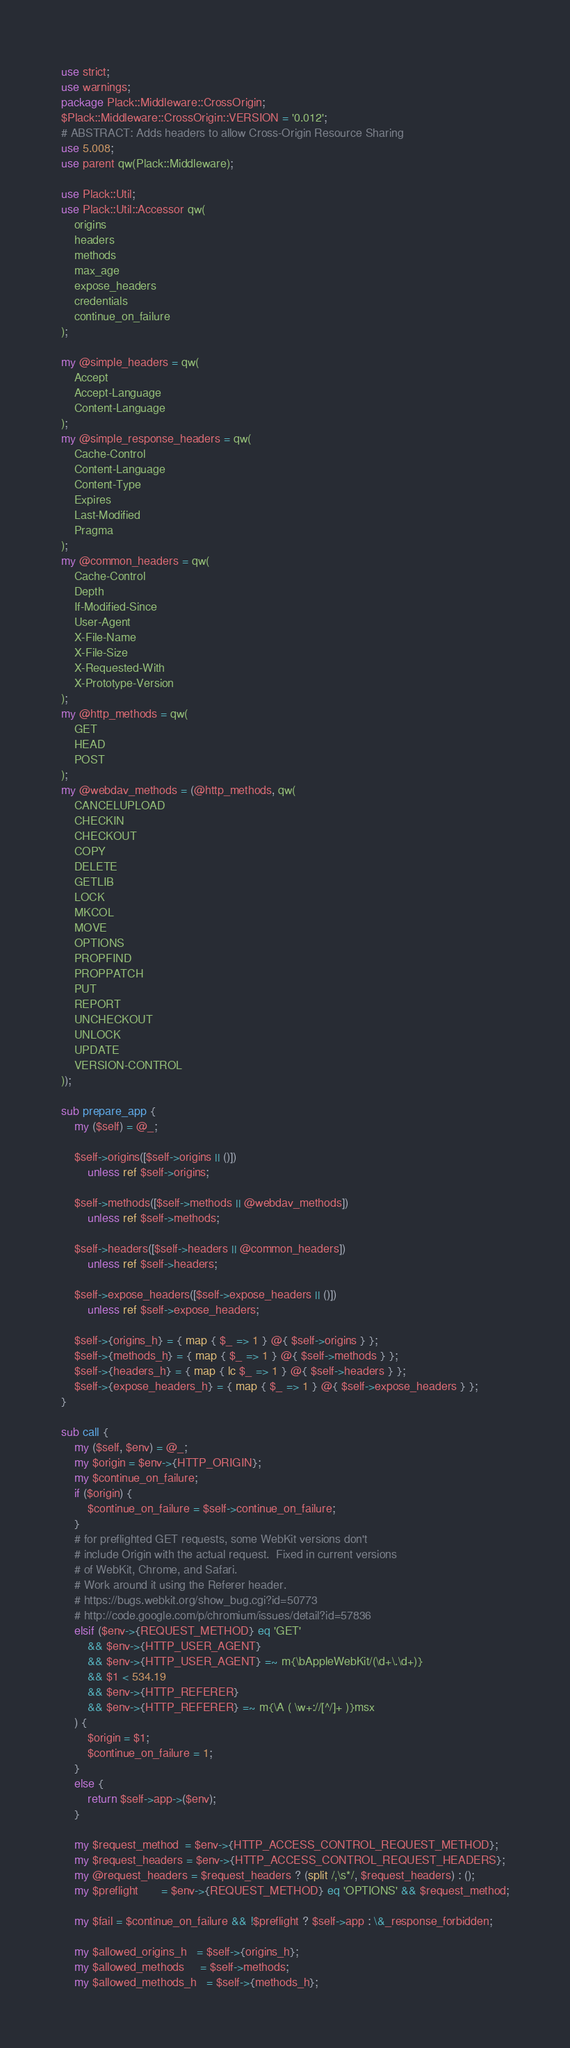<code> <loc_0><loc_0><loc_500><loc_500><_Perl_>use strict;
use warnings;
package Plack::Middleware::CrossOrigin;
$Plack::Middleware::CrossOrigin::VERSION = '0.012';
# ABSTRACT: Adds headers to allow Cross-Origin Resource Sharing
use 5.008;
use parent qw(Plack::Middleware);

use Plack::Util;
use Plack::Util::Accessor qw(
    origins
    headers
    methods
    max_age
    expose_headers
    credentials
    continue_on_failure
);

my @simple_headers = qw(
    Accept
    Accept-Language
    Content-Language
);
my @simple_response_headers = qw(
    Cache-Control
    Content-Language
    Content-Type
    Expires
    Last-Modified
    Pragma
);
my @common_headers = qw(
    Cache-Control
    Depth
    If-Modified-Since
    User-Agent
    X-File-Name
    X-File-Size
    X-Requested-With
    X-Prototype-Version
);
my @http_methods = qw(
    GET
    HEAD
    POST
);
my @webdav_methods = (@http_methods, qw(
    CANCELUPLOAD
    CHECKIN
    CHECKOUT
    COPY
    DELETE
    GETLIB
    LOCK
    MKCOL
    MOVE
    OPTIONS
    PROPFIND
    PROPPATCH
    PUT
    REPORT
    UNCHECKOUT
    UNLOCK
    UPDATE
    VERSION-CONTROL
));

sub prepare_app {
    my ($self) = @_;

    $self->origins([$self->origins || ()])
        unless ref $self->origins;

    $self->methods([$self->methods || @webdav_methods])
        unless ref $self->methods;

    $self->headers([$self->headers || @common_headers])
        unless ref $self->headers;

    $self->expose_headers([$self->expose_headers || ()])
        unless ref $self->expose_headers;

    $self->{origins_h} = { map { $_ => 1 } @{ $self->origins } };
    $self->{methods_h} = { map { $_ => 1 } @{ $self->methods } };
    $self->{headers_h} = { map { lc $_ => 1 } @{ $self->headers } };
    $self->{expose_headers_h} = { map { $_ => 1 } @{ $self->expose_headers } };
}

sub call {
    my ($self, $env) = @_;
    my $origin = $env->{HTTP_ORIGIN};
    my $continue_on_failure;
    if ($origin) {
        $continue_on_failure = $self->continue_on_failure;
    }
    # for preflighted GET requests, some WebKit versions don't
    # include Origin with the actual request.  Fixed in current versions
    # of WebKit, Chrome, and Safari.
    # Work around it using the Referer header.
    # https://bugs.webkit.org/show_bug.cgi?id=50773
    # http://code.google.com/p/chromium/issues/detail?id=57836
    elsif ($env->{REQUEST_METHOD} eq 'GET'
        && $env->{HTTP_USER_AGENT}
        && $env->{HTTP_USER_AGENT} =~ m{\bAppleWebKit/(\d+\.\d+)}
        && $1 < 534.19
        && $env->{HTTP_REFERER}
        && $env->{HTTP_REFERER} =~ m{\A ( \w+://[^/]+ )}msx
    ) {
        $origin = $1;
        $continue_on_failure = 1;
    }
    else {
        return $self->app->($env);
    }

    my $request_method  = $env->{HTTP_ACCESS_CONTROL_REQUEST_METHOD};
    my $request_headers = $env->{HTTP_ACCESS_CONTROL_REQUEST_HEADERS};
    my @request_headers = $request_headers ? (split /,\s*/, $request_headers) : ();
    my $preflight       = $env->{REQUEST_METHOD} eq 'OPTIONS' && $request_method;

    my $fail = $continue_on_failure && !$preflight ? $self->app : \&_response_forbidden;

    my $allowed_origins_h   = $self->{origins_h};
    my $allowed_methods     = $self->methods;
    my $allowed_methods_h   = $self->{methods_h};</code> 